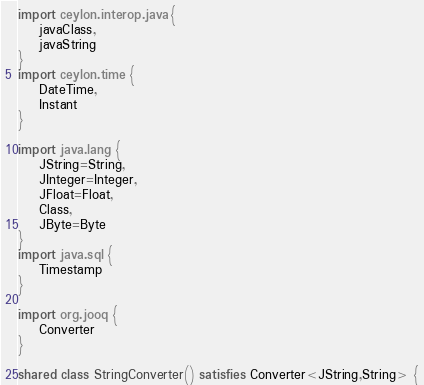<code> <loc_0><loc_0><loc_500><loc_500><_Ceylon_>import ceylon.interop.java {
    javaClass,
    javaString
}
import ceylon.time {
    DateTime,
    Instant
}

import java.lang {
    JString=String,
    JInteger=Integer,
    JFloat=Float,
    Class,
    JByte=Byte
}
import java.sql {
    Timestamp
}

import org.jooq {
    Converter
}

shared class StringConverter() satisfies Converter<JString,String> {</code> 